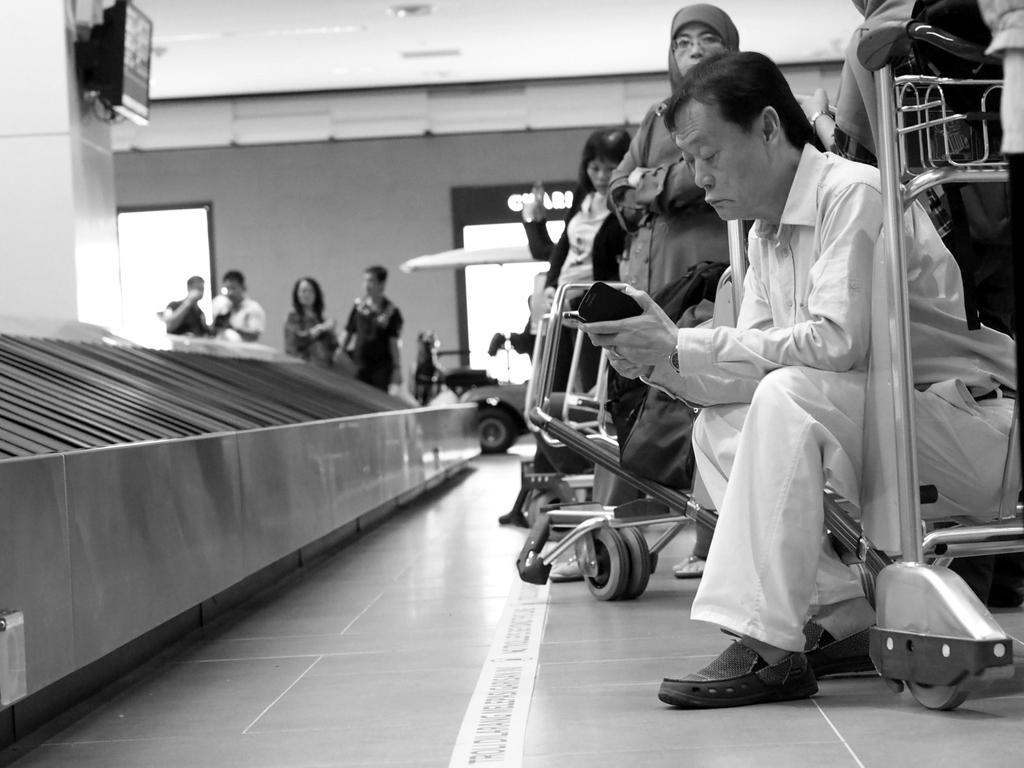What is the color scheme of the image? The image is black and white. Who or what can be seen in the image? There are people in the image. What type of transportation is present in the image? Trolleys are present in the image. What is visible beneath the people and trolleys? The floor is visible in the image. What is the purpose of the screen in the image? The purpose of the screen is not clear from the provided facts, but it is present in the image. What is the background of the image made of? There is a wall in the image, which likely makes up the background. Can you describe any other objects in the image? Other objects are present in the image, but their specific nature is not mentioned in the provided facts. What type of sweater is the man wearing in the image? There is no man or sweater present in the image; it features people and trolleys in a black and white setting. How many geese are visible on the wall in the image? There are no geese present in the image; it features people, trolleys, a floor, a screen, a wall, and other objects in a black and white setting. 